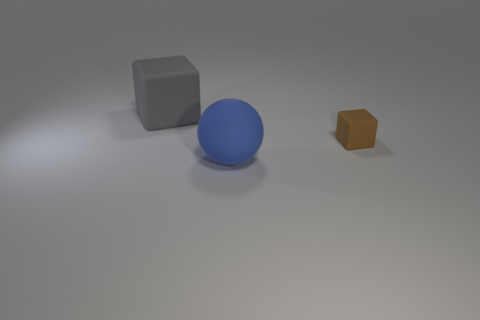Add 1 large brown shiny cylinders. How many objects exist? 4 Subtract all yellow spheres. How many red blocks are left? 0 Add 1 small gray matte balls. How many small gray matte balls exist? 1 Subtract all brown blocks. How many blocks are left? 1 Subtract 0 yellow blocks. How many objects are left? 3 Subtract all blocks. How many objects are left? 1 Subtract 1 spheres. How many spheres are left? 0 Subtract all gray cubes. Subtract all blue cylinders. How many cubes are left? 1 Subtract all brown rubber objects. Subtract all gray things. How many objects are left? 1 Add 1 big gray matte blocks. How many big gray matte blocks are left? 2 